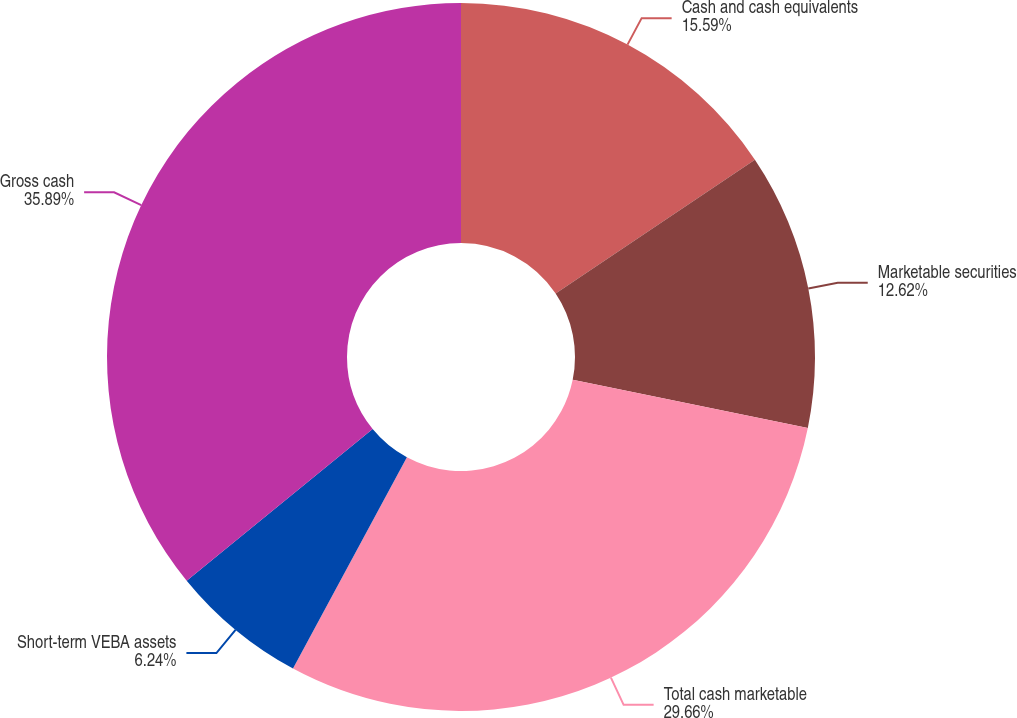Convert chart to OTSL. <chart><loc_0><loc_0><loc_500><loc_500><pie_chart><fcel>Cash and cash equivalents<fcel>Marketable securities<fcel>Total cash marketable<fcel>Short-term VEBA assets<fcel>Gross cash<nl><fcel>15.59%<fcel>12.62%<fcel>29.66%<fcel>6.24%<fcel>35.89%<nl></chart> 